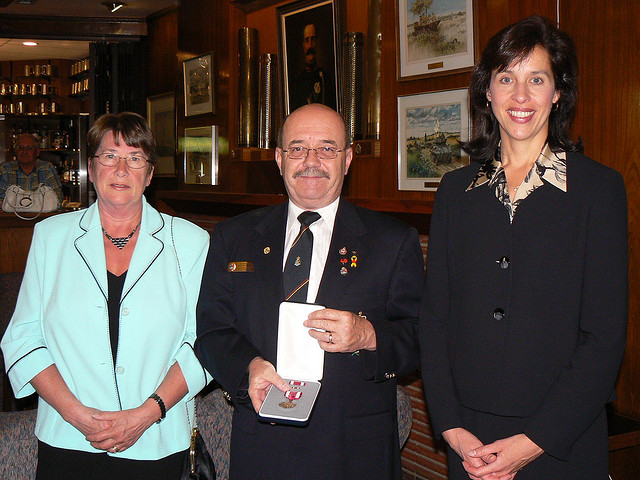Can you describe what the people are wearing? Certainly! From left to right: the first person is wearing a light turquoise blazer over a black top with a necklace, the person in the middle is dressed in a dark uniform with medals on the chest, and the third individual is wearing a black jacket with a stylish, patterned scarf. 